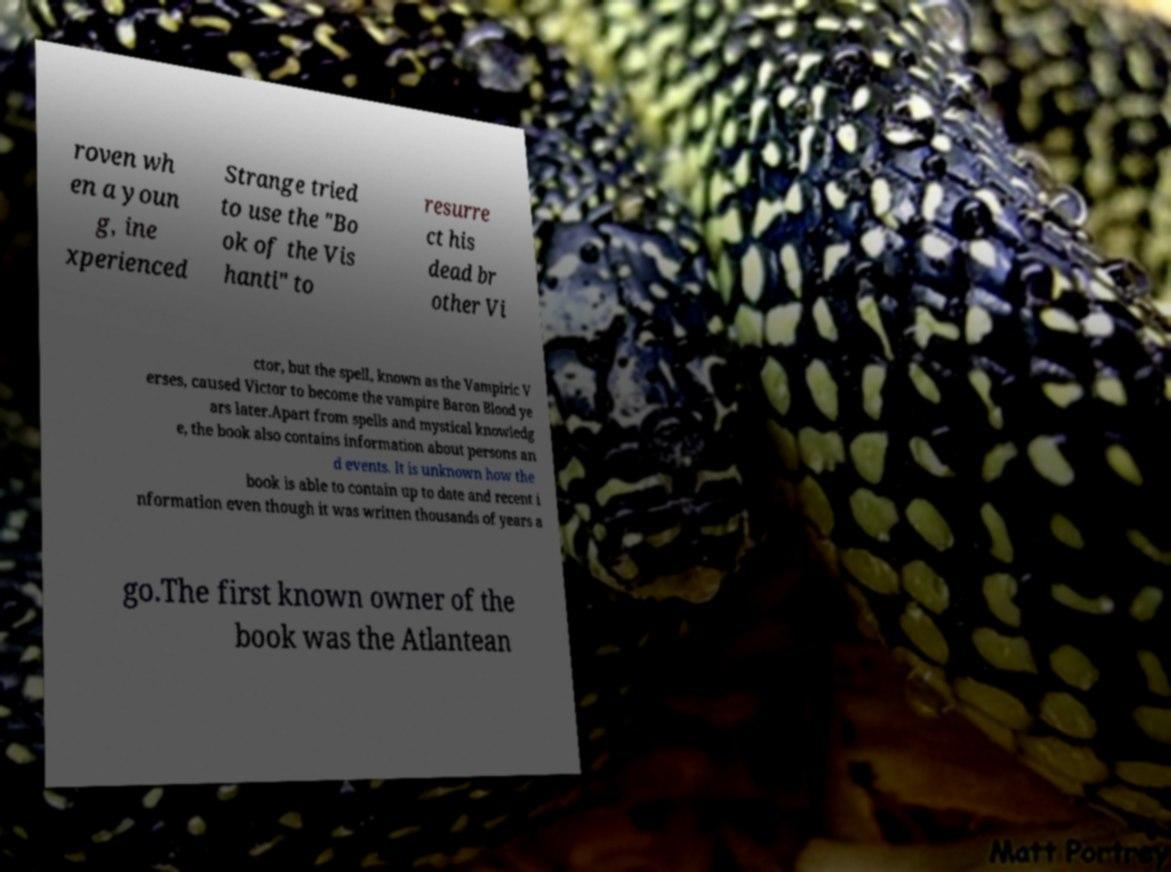Can you read and provide the text displayed in the image?This photo seems to have some interesting text. Can you extract and type it out for me? roven wh en a youn g, ine xperienced Strange tried to use the "Bo ok of the Vis hanti" to resurre ct his dead br other Vi ctor, but the spell, known as the Vampiric V erses, caused Victor to become the vampire Baron Blood ye ars later.Apart from spells and mystical knowledg e, the book also contains information about persons an d events. It is unknown how the book is able to contain up to date and recent i nformation even though it was written thousands of years a go.The first known owner of the book was the Atlantean 